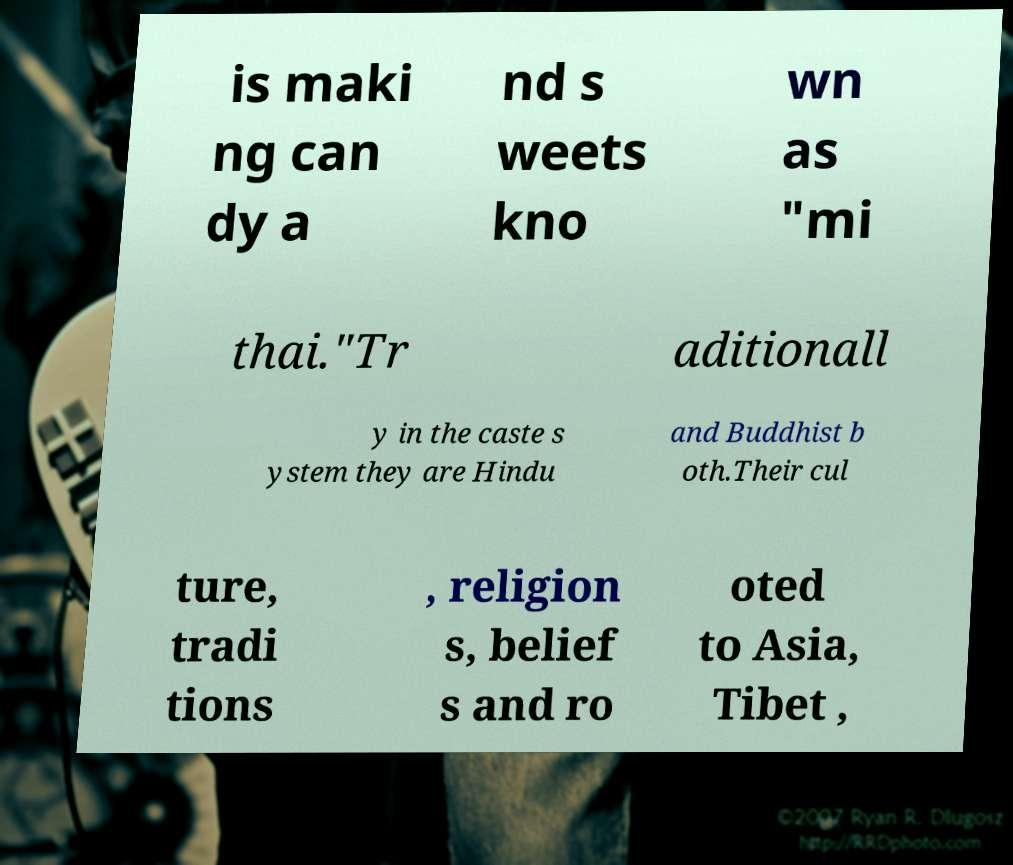I need the written content from this picture converted into text. Can you do that? is maki ng can dy a nd s weets kno wn as "mi thai."Tr aditionall y in the caste s ystem they are Hindu and Buddhist b oth.Their cul ture, tradi tions , religion s, belief s and ro oted to Asia, Tibet , 